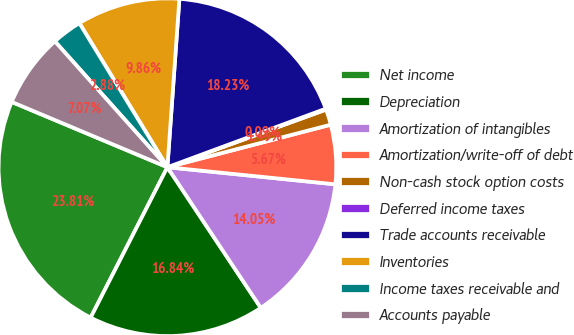Convert chart. <chart><loc_0><loc_0><loc_500><loc_500><pie_chart><fcel>Net income<fcel>Depreciation<fcel>Amortization of intangibles<fcel>Amortization/write-off of debt<fcel>Non-cash stock option costs<fcel>Deferred income taxes<fcel>Trade accounts receivable<fcel>Inventories<fcel>Income taxes receivable and<fcel>Accounts payable<nl><fcel>23.81%<fcel>16.84%<fcel>14.05%<fcel>5.67%<fcel>1.49%<fcel>0.09%<fcel>18.23%<fcel>9.86%<fcel>2.88%<fcel>7.07%<nl></chart> 